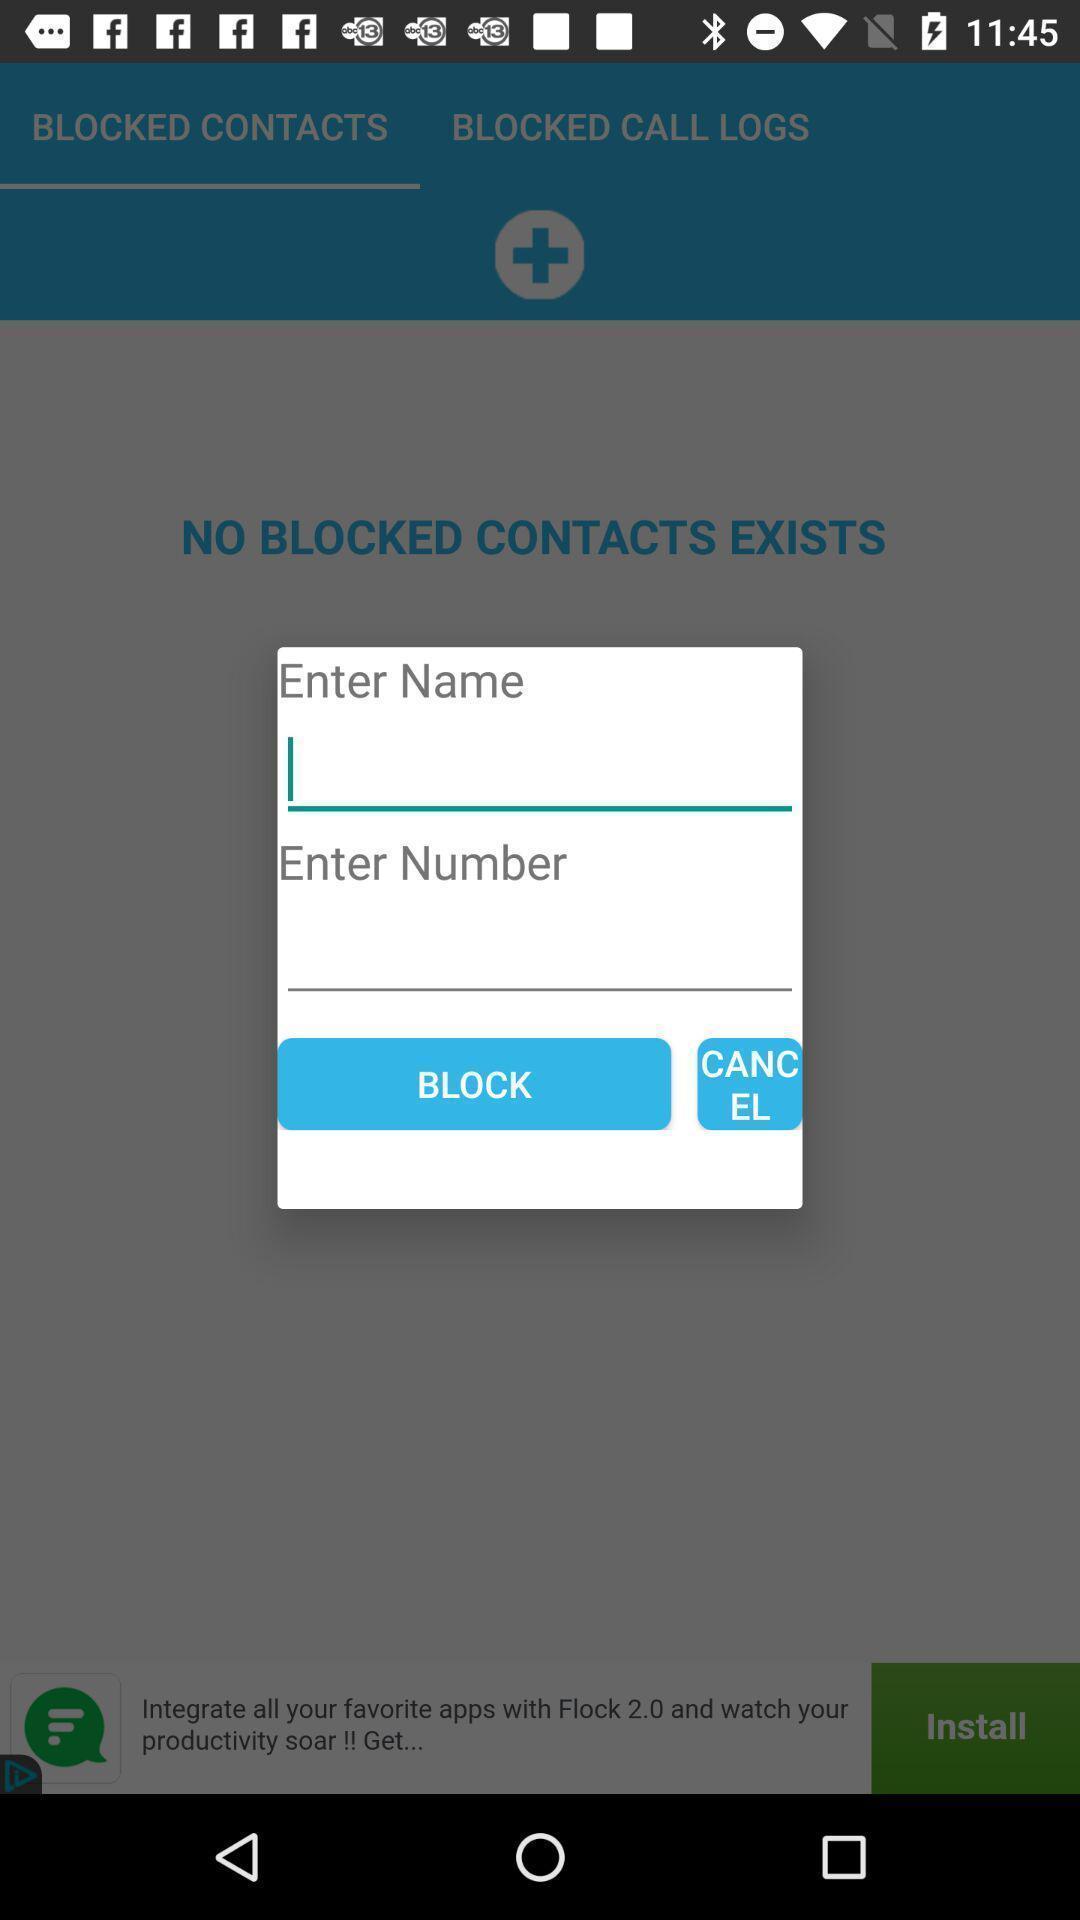Tell me about the visual elements in this screen capture. Popup in a home page. 